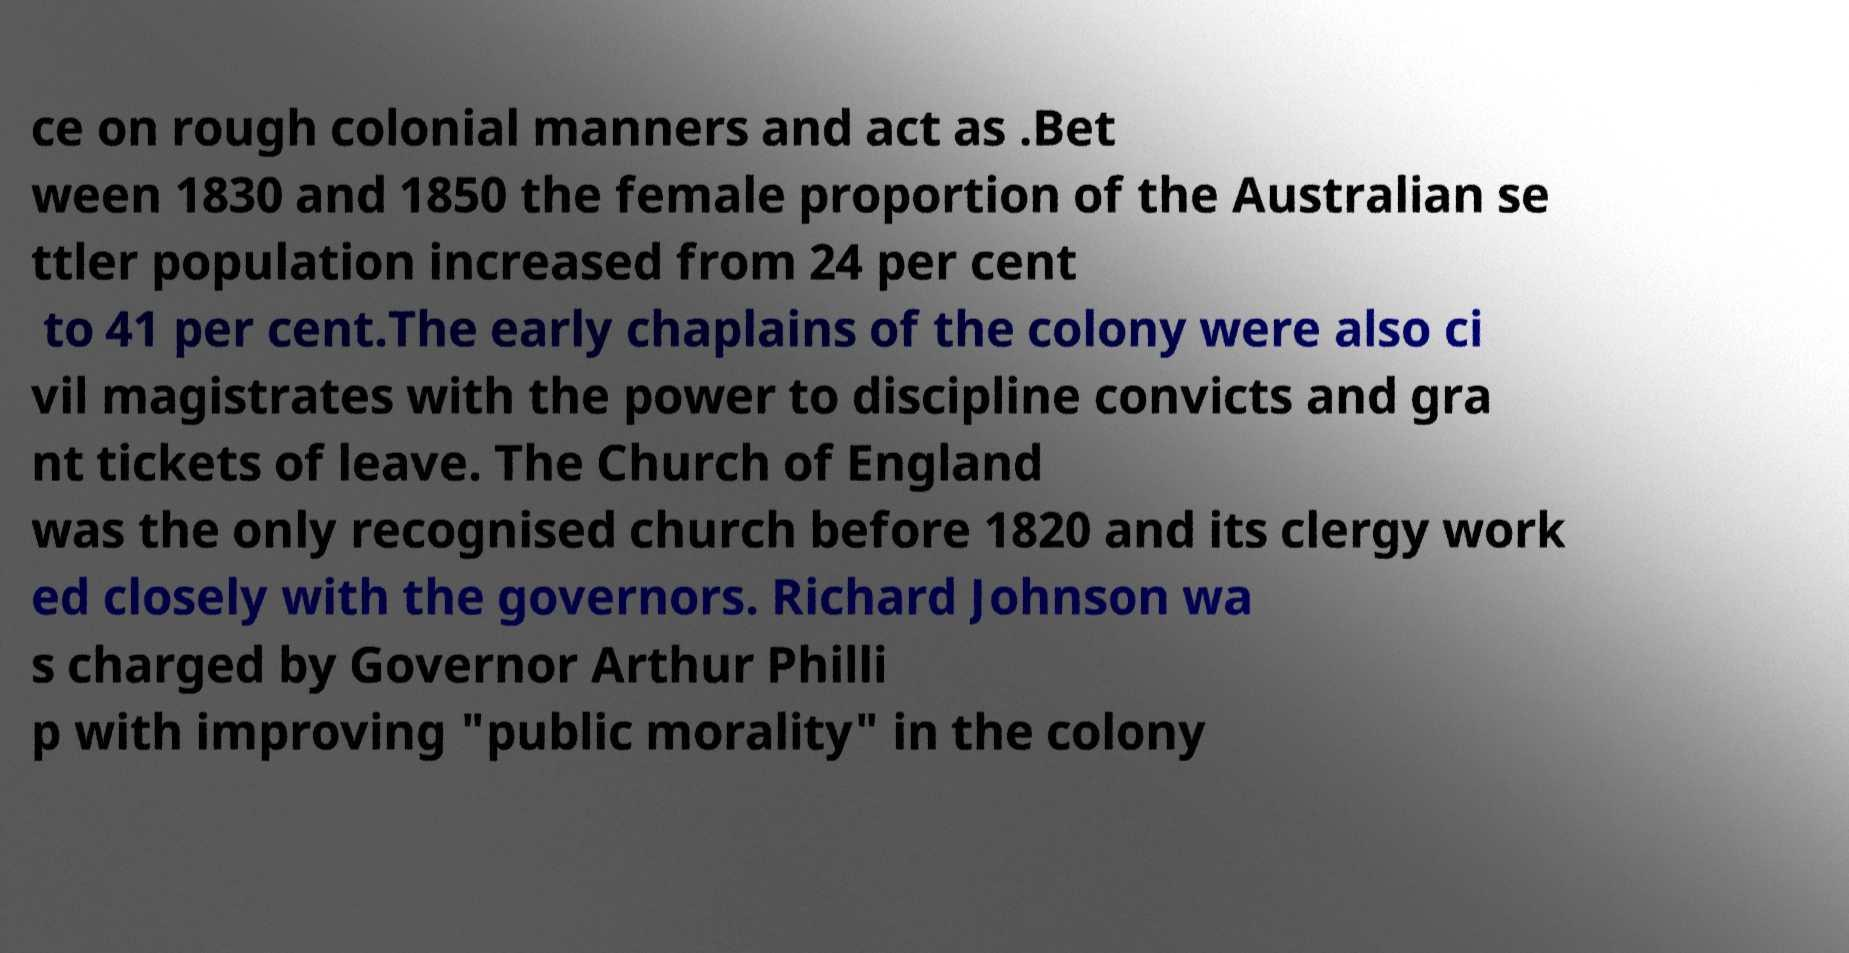Please identify and transcribe the text found in this image. ce on rough colonial manners and act as .Bet ween 1830 and 1850 the female proportion of the Australian se ttler population increased from 24 per cent to 41 per cent.The early chaplains of the colony were also ci vil magistrates with the power to discipline convicts and gra nt tickets of leave. The Church of England was the only recognised church before 1820 and its clergy work ed closely with the governors. Richard Johnson wa s charged by Governor Arthur Philli p with improving "public morality" in the colony 